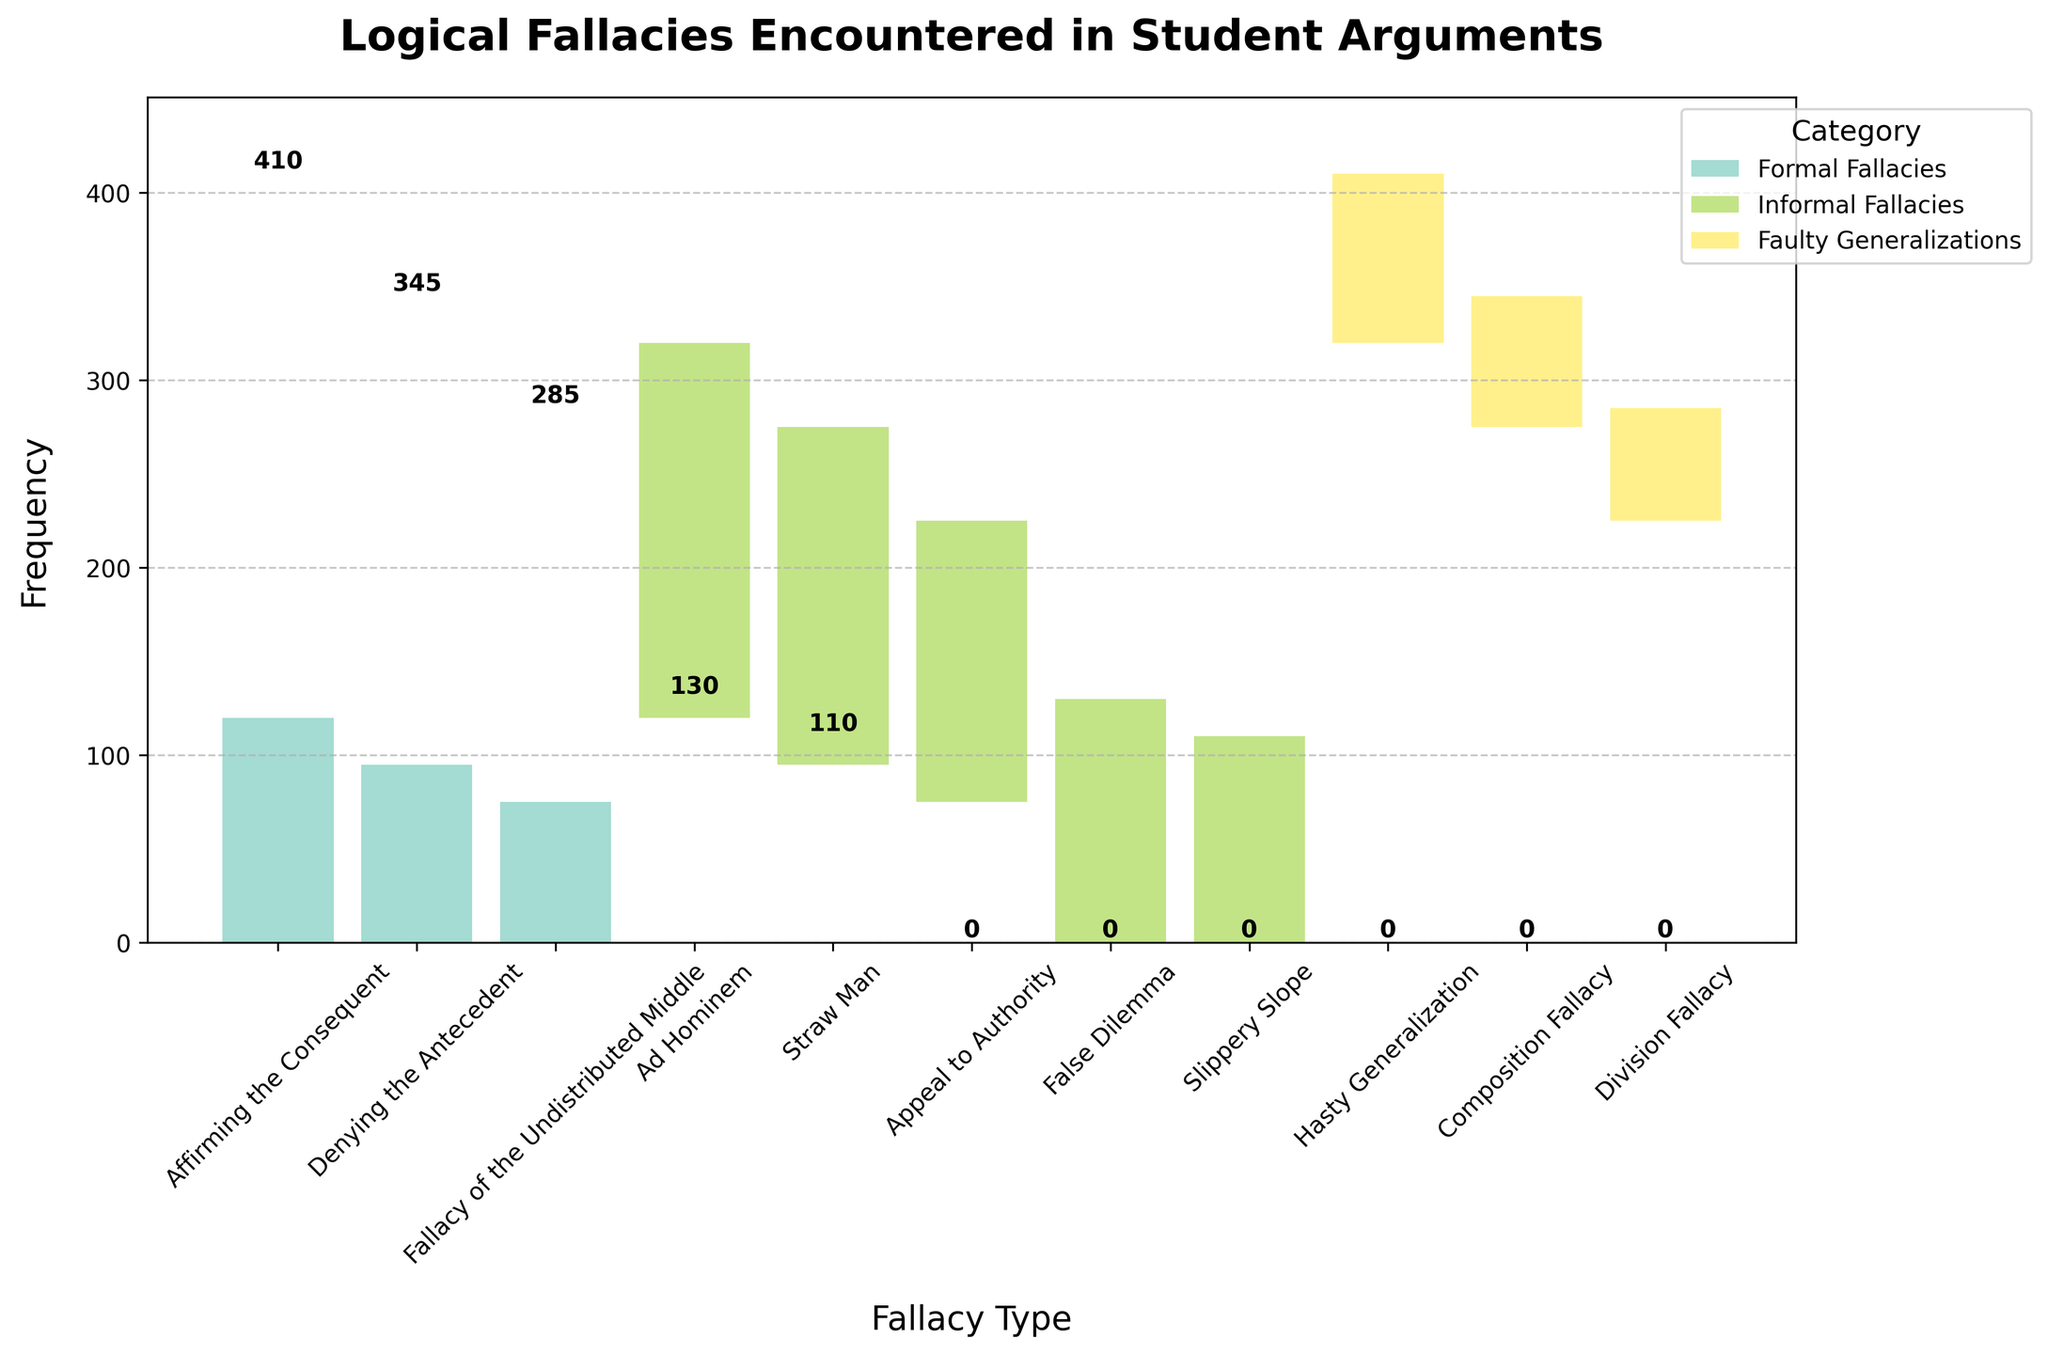What is the title of the chart? The title is usually displayed at the top of the chart and provides an overview of what the chart represents. Here, it is prominently displayed and reads “Logical Fallacies Encountered in Student Arguments.”
Answer: Logical Fallacies Encountered in Student Arguments How many fallacies are represented within the 'Informal Fallacies' category? To find this, count the number of labels associated with "Informal Fallacies" in the legend and the x-axis. Informal Fallacies include Ad Hominem, Straw Man, Appeal to Authority, False Dilemma, Slippery Slope.
Answer: 5 Which fallacy has the highest frequency? Look for the bar with the highest value in the chart. The highest bar visually represents the fallacy with the greatest frequency.
Answer: Ad Hominem What is the combined frequency of 'Denying the Antecedent' and 'Straw Man'? Identify the frequency values for both 'Denying the Antecedent' (95) and 'Straw Man' (180) from the chart and sum them. 95 + 180 = 275
Answer: 275 Which category has the most diverse set of fallacies based on their number? Count the unique fallacies within each category by looking at the legend and labels on the x-axis. Informal Fallacies have 5 while the other categories have fewer.
Answer: Informal Fallacies Between 'Hasty Generalization' and 'Slippery Slope', which fallacy is more frequent and by how much? Compare the heights of the bars corresponding to 'Hasty Generalization' (90) and 'Slippery Slope' (110). The difference in their frequencies is 110 - 90 = 20.
Answer: Slippery Slope, by 20 What is the total frequency of fallacies within the 'Formal Fallacies' category? Sum the frequency values for 'Affirming the Consequent' (120), 'Denying the Antecedent' (95), and 'Fallacy of the Undistributed Middle' (75). 120 + 95 + 75 = 290
Answer: 290 Compare the frequency of 'Composition Fallacy' with 'Division Fallacy'. Are they equal? Check the bar heights for 'Composition Fallacy' (70) and 'Division Fallacy' (60).
Answer: No Which fallacy type listed in 'Faulty Generalizations' has the lowest frequency? Within the 'Faulty Generalizations' category, identify the smallest bar. The 'Division Fallacy' (60) has the smallest frequency.
Answer: Division Fallacy What is the frequency difference between the most common and least common fallacy overall? The most common fallacy is 'Ad Hominem' (200), and the least common is 'Division Fallacy' (60). The difference is 200 - 60 = 140.
Answer: 140 